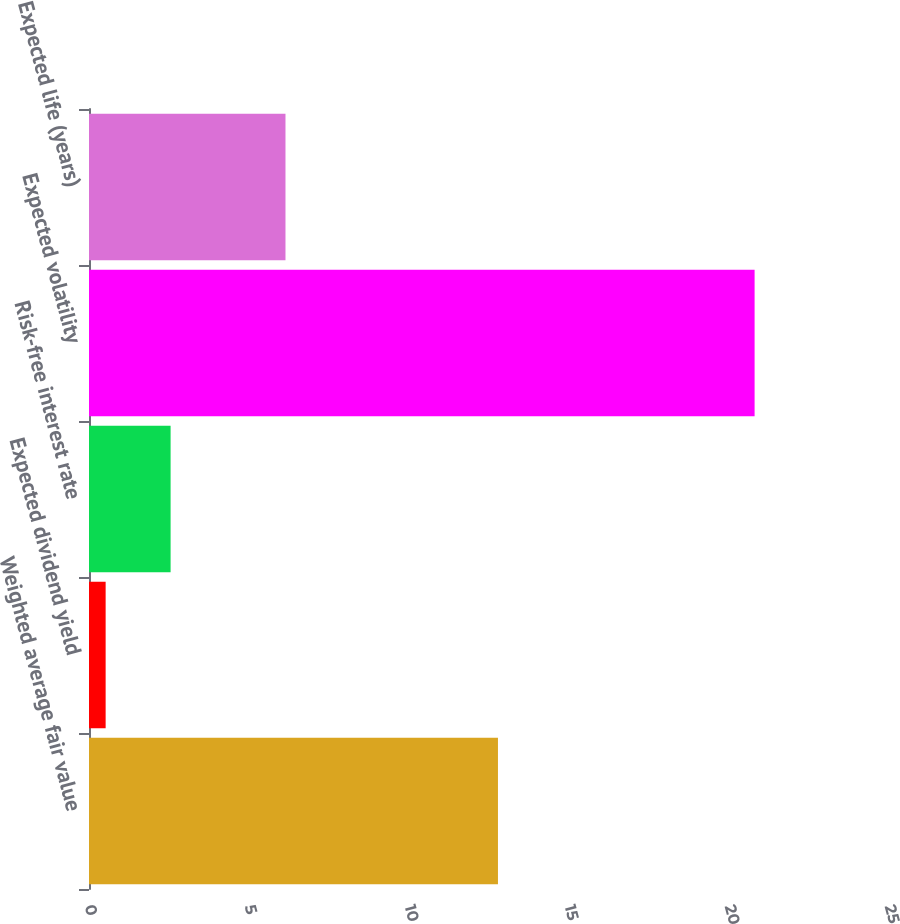Convert chart. <chart><loc_0><loc_0><loc_500><loc_500><bar_chart><fcel>Weighted average fair value<fcel>Expected dividend yield<fcel>Risk-free interest rate<fcel>Expected volatility<fcel>Expected life (years)<nl><fcel>12.78<fcel>0.52<fcel>2.55<fcel>20.8<fcel>6.14<nl></chart> 